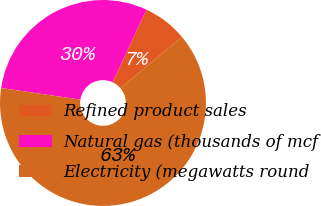Convert chart to OTSL. <chart><loc_0><loc_0><loc_500><loc_500><pie_chart><fcel>Refined product sales<fcel>Natural gas (thousands of mcf<fcel>Electricity (megawatts round<nl><fcel>6.97%<fcel>29.61%<fcel>63.43%<nl></chart> 